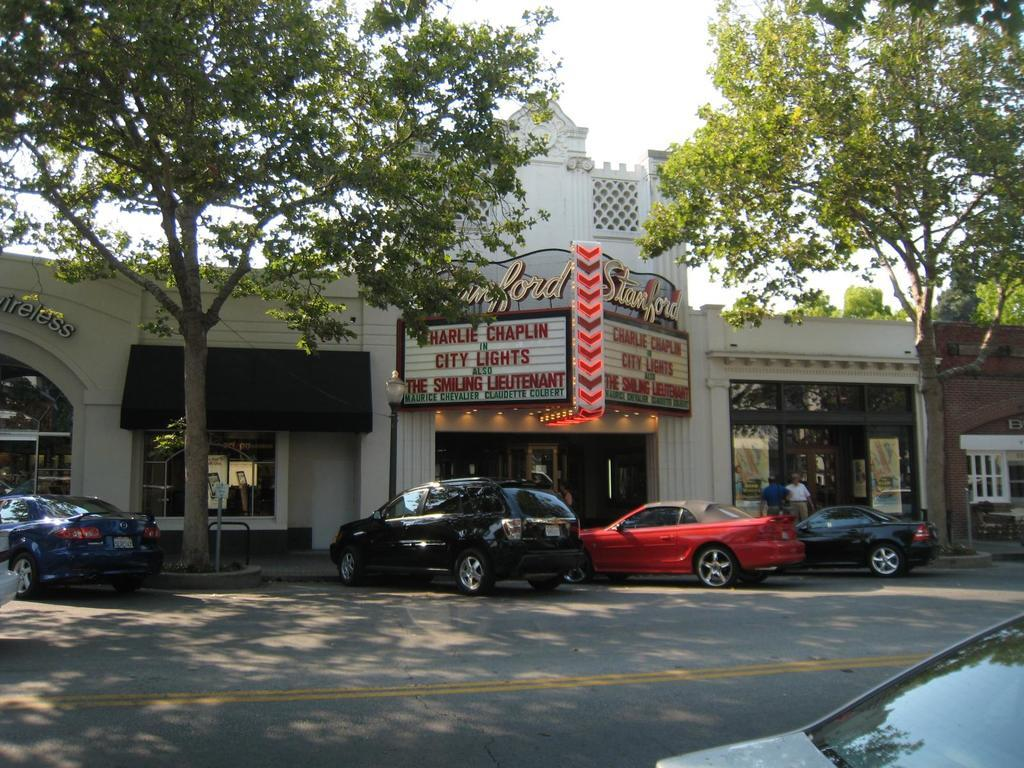What can be seen on the road in the image? There are cars parked on the road in the image. What type of establishment is located in the middle of the image? There appears to be a store in the middle of the image. What kind of vegetation is present on either side of the image? There are trees on either side of the image. What is visible at the top of the image? The sky is visible at the top of the image. How many brothers are standing in front of the store in the image? There is no mention of brothers in the image, as it features cars parked on the road, a store, trees, and the sky. What type of property is the store located on in the image? The image does not provide information about the property the store is located on. 